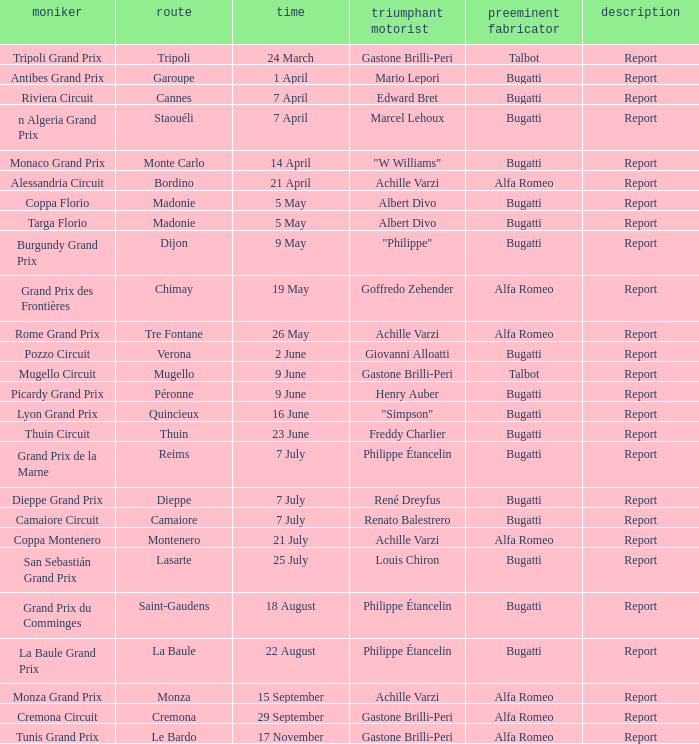What Winning driver has a Name of mugello circuit? Gastone Brilli-Peri. 